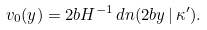<formula> <loc_0><loc_0><loc_500><loc_500>v _ { 0 } ( y ) = 2 b H ^ { - 1 } \, d n ( 2 b y \, | \, \kappa ^ { \prime } ) .</formula> 